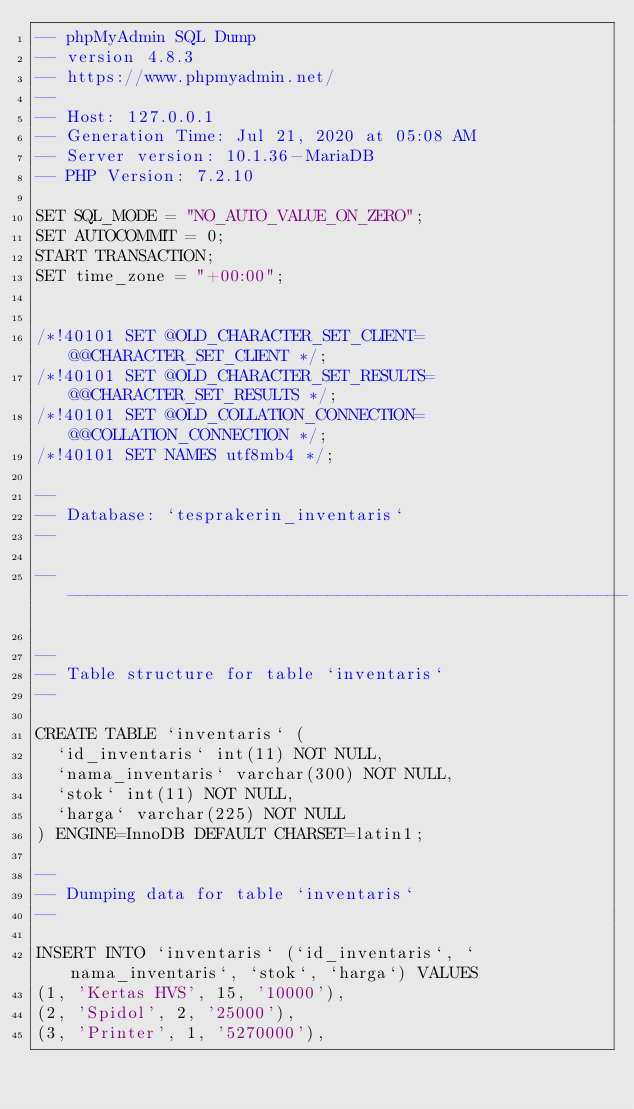Convert code to text. <code><loc_0><loc_0><loc_500><loc_500><_SQL_>-- phpMyAdmin SQL Dump
-- version 4.8.3
-- https://www.phpmyadmin.net/
--
-- Host: 127.0.0.1
-- Generation Time: Jul 21, 2020 at 05:08 AM
-- Server version: 10.1.36-MariaDB
-- PHP Version: 7.2.10

SET SQL_MODE = "NO_AUTO_VALUE_ON_ZERO";
SET AUTOCOMMIT = 0;
START TRANSACTION;
SET time_zone = "+00:00";


/*!40101 SET @OLD_CHARACTER_SET_CLIENT=@@CHARACTER_SET_CLIENT */;
/*!40101 SET @OLD_CHARACTER_SET_RESULTS=@@CHARACTER_SET_RESULTS */;
/*!40101 SET @OLD_COLLATION_CONNECTION=@@COLLATION_CONNECTION */;
/*!40101 SET NAMES utf8mb4 */;

--
-- Database: `tesprakerin_inventaris`
--

-- --------------------------------------------------------

--
-- Table structure for table `inventaris`
--

CREATE TABLE `inventaris` (
  `id_inventaris` int(11) NOT NULL,
  `nama_inventaris` varchar(300) NOT NULL,
  `stok` int(11) NOT NULL,
  `harga` varchar(225) NOT NULL
) ENGINE=InnoDB DEFAULT CHARSET=latin1;

--
-- Dumping data for table `inventaris`
--

INSERT INTO `inventaris` (`id_inventaris`, `nama_inventaris`, `stok`, `harga`) VALUES
(1, 'Kertas HVS', 15, '10000'),
(2, 'Spidol', 2, '25000'),
(3, 'Printer', 1, '5270000'),</code> 